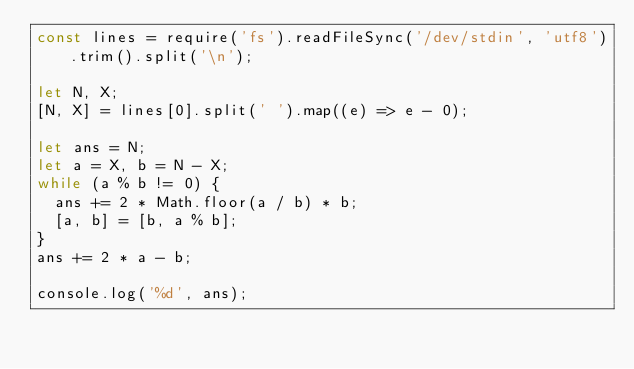<code> <loc_0><loc_0><loc_500><loc_500><_JavaScript_>const lines = require('fs').readFileSync('/dev/stdin', 'utf8').trim().split('\n');

let N, X;
[N, X] = lines[0].split(' ').map((e) => e - 0);

let ans = N;
let a = X, b = N - X;
while (a % b != 0) {
  ans += 2 * Math.floor(a / b) * b;
  [a, b] = [b, a % b];
}
ans += 2 * a - b;

console.log('%d', ans);
</code> 